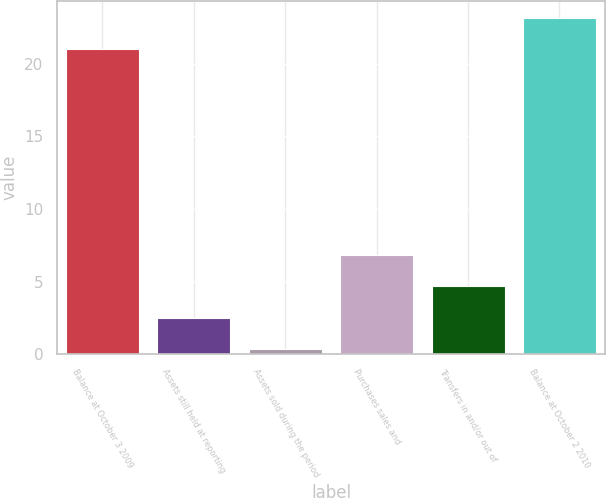<chart> <loc_0><loc_0><loc_500><loc_500><bar_chart><fcel>Balance at October 3 2009<fcel>Assets still held at reporting<fcel>Assets sold during the period<fcel>Purchases sales and<fcel>Transfers in and/or out of<fcel>Balance at October 2 2010<nl><fcel>21<fcel>2.52<fcel>0.35<fcel>6.86<fcel>4.69<fcel>23.16<nl></chart> 